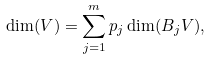Convert formula to latex. <formula><loc_0><loc_0><loc_500><loc_500>\dim ( V ) = \sum _ { j = 1 } ^ { m } p _ { j } \dim ( B _ { j } V ) ,</formula> 